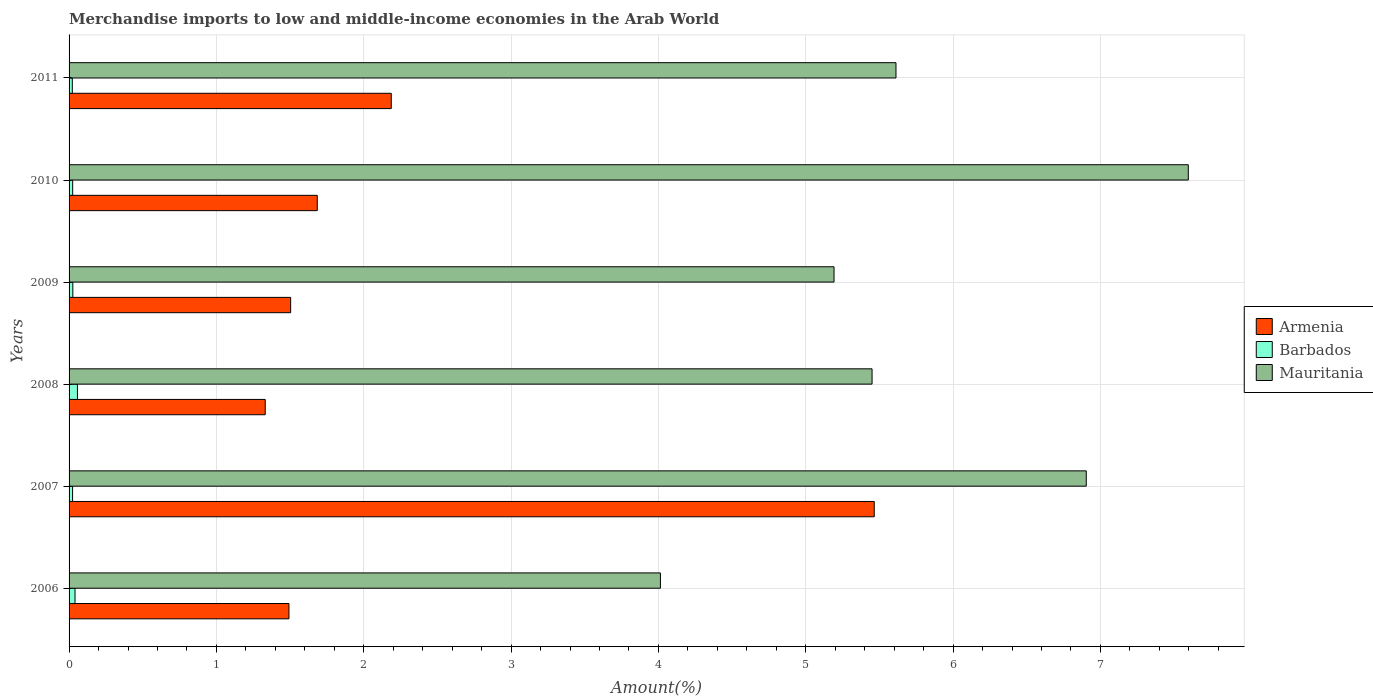How many different coloured bars are there?
Give a very brief answer. 3. How many groups of bars are there?
Your response must be concise. 6. Are the number of bars per tick equal to the number of legend labels?
Offer a very short reply. Yes. How many bars are there on the 1st tick from the top?
Keep it short and to the point. 3. In how many cases, is the number of bars for a given year not equal to the number of legend labels?
Offer a very short reply. 0. What is the percentage of amount earned from merchandise imports in Barbados in 2006?
Your answer should be compact. 0.04. Across all years, what is the maximum percentage of amount earned from merchandise imports in Barbados?
Your answer should be compact. 0.06. Across all years, what is the minimum percentage of amount earned from merchandise imports in Mauritania?
Provide a succinct answer. 4.01. In which year was the percentage of amount earned from merchandise imports in Barbados minimum?
Offer a very short reply. 2011. What is the total percentage of amount earned from merchandise imports in Armenia in the graph?
Your response must be concise. 13.66. What is the difference between the percentage of amount earned from merchandise imports in Mauritania in 2008 and that in 2011?
Offer a very short reply. -0.16. What is the difference between the percentage of amount earned from merchandise imports in Barbados in 2011 and the percentage of amount earned from merchandise imports in Armenia in 2008?
Make the answer very short. -1.31. What is the average percentage of amount earned from merchandise imports in Barbados per year?
Your response must be concise. 0.03. In the year 2008, what is the difference between the percentage of amount earned from merchandise imports in Barbados and percentage of amount earned from merchandise imports in Armenia?
Your answer should be compact. -1.27. What is the ratio of the percentage of amount earned from merchandise imports in Mauritania in 2010 to that in 2011?
Give a very brief answer. 1.35. Is the percentage of amount earned from merchandise imports in Armenia in 2008 less than that in 2010?
Provide a short and direct response. Yes. What is the difference between the highest and the second highest percentage of amount earned from merchandise imports in Mauritania?
Give a very brief answer. 0.69. What is the difference between the highest and the lowest percentage of amount earned from merchandise imports in Mauritania?
Offer a very short reply. 3.58. Is the sum of the percentage of amount earned from merchandise imports in Armenia in 2006 and 2007 greater than the maximum percentage of amount earned from merchandise imports in Barbados across all years?
Keep it short and to the point. Yes. What does the 3rd bar from the top in 2009 represents?
Provide a succinct answer. Armenia. What does the 1st bar from the bottom in 2011 represents?
Your answer should be very brief. Armenia. Is it the case that in every year, the sum of the percentage of amount earned from merchandise imports in Armenia and percentage of amount earned from merchandise imports in Barbados is greater than the percentage of amount earned from merchandise imports in Mauritania?
Your answer should be compact. No. Are all the bars in the graph horizontal?
Your response must be concise. Yes. Are the values on the major ticks of X-axis written in scientific E-notation?
Provide a short and direct response. No. Does the graph contain any zero values?
Ensure brevity in your answer.  No. Where does the legend appear in the graph?
Provide a short and direct response. Center right. How many legend labels are there?
Make the answer very short. 3. How are the legend labels stacked?
Give a very brief answer. Vertical. What is the title of the graph?
Make the answer very short. Merchandise imports to low and middle-income economies in the Arab World. Does "Libya" appear as one of the legend labels in the graph?
Offer a very short reply. No. What is the label or title of the X-axis?
Your answer should be compact. Amount(%). What is the Amount(%) in Armenia in 2006?
Your answer should be compact. 1.49. What is the Amount(%) of Barbados in 2006?
Offer a terse response. 0.04. What is the Amount(%) in Mauritania in 2006?
Keep it short and to the point. 4.01. What is the Amount(%) in Armenia in 2007?
Provide a succinct answer. 5.47. What is the Amount(%) in Barbados in 2007?
Your answer should be compact. 0.02. What is the Amount(%) of Mauritania in 2007?
Offer a very short reply. 6.9. What is the Amount(%) of Armenia in 2008?
Keep it short and to the point. 1.33. What is the Amount(%) of Barbados in 2008?
Give a very brief answer. 0.06. What is the Amount(%) in Mauritania in 2008?
Your response must be concise. 5.45. What is the Amount(%) of Armenia in 2009?
Offer a very short reply. 1.5. What is the Amount(%) in Barbados in 2009?
Provide a short and direct response. 0.03. What is the Amount(%) of Mauritania in 2009?
Make the answer very short. 5.19. What is the Amount(%) in Armenia in 2010?
Provide a succinct answer. 1.68. What is the Amount(%) in Barbados in 2010?
Offer a terse response. 0.02. What is the Amount(%) of Mauritania in 2010?
Give a very brief answer. 7.6. What is the Amount(%) in Armenia in 2011?
Offer a terse response. 2.19. What is the Amount(%) of Barbados in 2011?
Offer a terse response. 0.02. What is the Amount(%) in Mauritania in 2011?
Your answer should be very brief. 5.61. Across all years, what is the maximum Amount(%) in Armenia?
Your response must be concise. 5.47. Across all years, what is the maximum Amount(%) of Barbados?
Your answer should be very brief. 0.06. Across all years, what is the maximum Amount(%) of Mauritania?
Offer a very short reply. 7.6. Across all years, what is the minimum Amount(%) of Armenia?
Make the answer very short. 1.33. Across all years, what is the minimum Amount(%) in Barbados?
Your response must be concise. 0.02. Across all years, what is the minimum Amount(%) in Mauritania?
Your answer should be compact. 4.01. What is the total Amount(%) of Armenia in the graph?
Your response must be concise. 13.66. What is the total Amount(%) in Barbados in the graph?
Your response must be concise. 0.19. What is the total Amount(%) in Mauritania in the graph?
Ensure brevity in your answer.  34.77. What is the difference between the Amount(%) of Armenia in 2006 and that in 2007?
Keep it short and to the point. -3.97. What is the difference between the Amount(%) of Barbados in 2006 and that in 2007?
Your response must be concise. 0.02. What is the difference between the Amount(%) in Mauritania in 2006 and that in 2007?
Offer a very short reply. -2.89. What is the difference between the Amount(%) in Armenia in 2006 and that in 2008?
Give a very brief answer. 0.16. What is the difference between the Amount(%) of Barbados in 2006 and that in 2008?
Give a very brief answer. -0.02. What is the difference between the Amount(%) of Mauritania in 2006 and that in 2008?
Provide a short and direct response. -1.44. What is the difference between the Amount(%) in Armenia in 2006 and that in 2009?
Offer a terse response. -0.01. What is the difference between the Amount(%) of Barbados in 2006 and that in 2009?
Make the answer very short. 0.01. What is the difference between the Amount(%) in Mauritania in 2006 and that in 2009?
Your answer should be compact. -1.18. What is the difference between the Amount(%) in Armenia in 2006 and that in 2010?
Ensure brevity in your answer.  -0.19. What is the difference between the Amount(%) in Barbados in 2006 and that in 2010?
Keep it short and to the point. 0.02. What is the difference between the Amount(%) in Mauritania in 2006 and that in 2010?
Offer a terse response. -3.58. What is the difference between the Amount(%) of Armenia in 2006 and that in 2011?
Give a very brief answer. -0.69. What is the difference between the Amount(%) of Barbados in 2006 and that in 2011?
Offer a very short reply. 0.02. What is the difference between the Amount(%) of Mauritania in 2006 and that in 2011?
Your answer should be very brief. -1.6. What is the difference between the Amount(%) of Armenia in 2007 and that in 2008?
Offer a very short reply. 4.13. What is the difference between the Amount(%) of Barbados in 2007 and that in 2008?
Keep it short and to the point. -0.03. What is the difference between the Amount(%) of Mauritania in 2007 and that in 2008?
Your answer should be compact. 1.45. What is the difference between the Amount(%) of Armenia in 2007 and that in 2009?
Offer a very short reply. 3.96. What is the difference between the Amount(%) of Barbados in 2007 and that in 2009?
Keep it short and to the point. -0. What is the difference between the Amount(%) of Mauritania in 2007 and that in 2009?
Provide a succinct answer. 1.71. What is the difference between the Amount(%) in Armenia in 2007 and that in 2010?
Make the answer very short. 3.78. What is the difference between the Amount(%) of Barbados in 2007 and that in 2010?
Make the answer very short. -0. What is the difference between the Amount(%) of Mauritania in 2007 and that in 2010?
Give a very brief answer. -0.69. What is the difference between the Amount(%) of Armenia in 2007 and that in 2011?
Make the answer very short. 3.28. What is the difference between the Amount(%) in Barbados in 2007 and that in 2011?
Keep it short and to the point. 0. What is the difference between the Amount(%) of Mauritania in 2007 and that in 2011?
Your answer should be very brief. 1.29. What is the difference between the Amount(%) of Armenia in 2008 and that in 2009?
Offer a very short reply. -0.17. What is the difference between the Amount(%) of Barbados in 2008 and that in 2009?
Your answer should be compact. 0.03. What is the difference between the Amount(%) of Mauritania in 2008 and that in 2009?
Keep it short and to the point. 0.26. What is the difference between the Amount(%) of Armenia in 2008 and that in 2010?
Give a very brief answer. -0.35. What is the difference between the Amount(%) in Barbados in 2008 and that in 2010?
Provide a succinct answer. 0.03. What is the difference between the Amount(%) in Mauritania in 2008 and that in 2010?
Provide a short and direct response. -2.15. What is the difference between the Amount(%) in Armenia in 2008 and that in 2011?
Your response must be concise. -0.86. What is the difference between the Amount(%) in Barbados in 2008 and that in 2011?
Your answer should be very brief. 0.03. What is the difference between the Amount(%) of Mauritania in 2008 and that in 2011?
Keep it short and to the point. -0.16. What is the difference between the Amount(%) in Armenia in 2009 and that in 2010?
Keep it short and to the point. -0.18. What is the difference between the Amount(%) in Barbados in 2009 and that in 2010?
Provide a succinct answer. 0. What is the difference between the Amount(%) of Mauritania in 2009 and that in 2010?
Keep it short and to the point. -2.4. What is the difference between the Amount(%) of Armenia in 2009 and that in 2011?
Your answer should be compact. -0.68. What is the difference between the Amount(%) of Barbados in 2009 and that in 2011?
Make the answer very short. 0. What is the difference between the Amount(%) of Mauritania in 2009 and that in 2011?
Keep it short and to the point. -0.42. What is the difference between the Amount(%) in Armenia in 2010 and that in 2011?
Provide a short and direct response. -0.5. What is the difference between the Amount(%) of Barbados in 2010 and that in 2011?
Ensure brevity in your answer.  0. What is the difference between the Amount(%) in Mauritania in 2010 and that in 2011?
Make the answer very short. 1.98. What is the difference between the Amount(%) in Armenia in 2006 and the Amount(%) in Barbados in 2007?
Ensure brevity in your answer.  1.47. What is the difference between the Amount(%) in Armenia in 2006 and the Amount(%) in Mauritania in 2007?
Make the answer very short. -5.41. What is the difference between the Amount(%) in Barbados in 2006 and the Amount(%) in Mauritania in 2007?
Your response must be concise. -6.86. What is the difference between the Amount(%) of Armenia in 2006 and the Amount(%) of Barbados in 2008?
Provide a succinct answer. 1.44. What is the difference between the Amount(%) of Armenia in 2006 and the Amount(%) of Mauritania in 2008?
Offer a very short reply. -3.96. What is the difference between the Amount(%) of Barbados in 2006 and the Amount(%) of Mauritania in 2008?
Provide a short and direct response. -5.41. What is the difference between the Amount(%) in Armenia in 2006 and the Amount(%) in Barbados in 2009?
Provide a short and direct response. 1.47. What is the difference between the Amount(%) of Armenia in 2006 and the Amount(%) of Mauritania in 2009?
Provide a short and direct response. -3.7. What is the difference between the Amount(%) of Barbados in 2006 and the Amount(%) of Mauritania in 2009?
Your answer should be compact. -5.15. What is the difference between the Amount(%) of Armenia in 2006 and the Amount(%) of Barbados in 2010?
Provide a succinct answer. 1.47. What is the difference between the Amount(%) of Armenia in 2006 and the Amount(%) of Mauritania in 2010?
Make the answer very short. -6.1. What is the difference between the Amount(%) of Barbados in 2006 and the Amount(%) of Mauritania in 2010?
Offer a very short reply. -7.56. What is the difference between the Amount(%) of Armenia in 2006 and the Amount(%) of Barbados in 2011?
Provide a succinct answer. 1.47. What is the difference between the Amount(%) of Armenia in 2006 and the Amount(%) of Mauritania in 2011?
Make the answer very short. -4.12. What is the difference between the Amount(%) in Barbados in 2006 and the Amount(%) in Mauritania in 2011?
Your answer should be very brief. -5.57. What is the difference between the Amount(%) of Armenia in 2007 and the Amount(%) of Barbados in 2008?
Offer a terse response. 5.41. What is the difference between the Amount(%) of Armenia in 2007 and the Amount(%) of Mauritania in 2008?
Ensure brevity in your answer.  0.01. What is the difference between the Amount(%) of Barbados in 2007 and the Amount(%) of Mauritania in 2008?
Offer a terse response. -5.43. What is the difference between the Amount(%) in Armenia in 2007 and the Amount(%) in Barbados in 2009?
Give a very brief answer. 5.44. What is the difference between the Amount(%) in Armenia in 2007 and the Amount(%) in Mauritania in 2009?
Your answer should be compact. 0.27. What is the difference between the Amount(%) in Barbados in 2007 and the Amount(%) in Mauritania in 2009?
Make the answer very short. -5.17. What is the difference between the Amount(%) of Armenia in 2007 and the Amount(%) of Barbados in 2010?
Keep it short and to the point. 5.44. What is the difference between the Amount(%) in Armenia in 2007 and the Amount(%) in Mauritania in 2010?
Your answer should be very brief. -2.13. What is the difference between the Amount(%) in Barbados in 2007 and the Amount(%) in Mauritania in 2010?
Provide a short and direct response. -7.57. What is the difference between the Amount(%) in Armenia in 2007 and the Amount(%) in Barbados in 2011?
Keep it short and to the point. 5.44. What is the difference between the Amount(%) of Armenia in 2007 and the Amount(%) of Mauritania in 2011?
Your answer should be very brief. -0.15. What is the difference between the Amount(%) in Barbados in 2007 and the Amount(%) in Mauritania in 2011?
Make the answer very short. -5.59. What is the difference between the Amount(%) in Armenia in 2008 and the Amount(%) in Barbados in 2009?
Offer a very short reply. 1.31. What is the difference between the Amount(%) of Armenia in 2008 and the Amount(%) of Mauritania in 2009?
Provide a succinct answer. -3.86. What is the difference between the Amount(%) in Barbados in 2008 and the Amount(%) in Mauritania in 2009?
Keep it short and to the point. -5.14. What is the difference between the Amount(%) of Armenia in 2008 and the Amount(%) of Barbados in 2010?
Provide a succinct answer. 1.31. What is the difference between the Amount(%) of Armenia in 2008 and the Amount(%) of Mauritania in 2010?
Offer a terse response. -6.27. What is the difference between the Amount(%) in Barbados in 2008 and the Amount(%) in Mauritania in 2010?
Give a very brief answer. -7.54. What is the difference between the Amount(%) in Armenia in 2008 and the Amount(%) in Barbados in 2011?
Provide a succinct answer. 1.31. What is the difference between the Amount(%) in Armenia in 2008 and the Amount(%) in Mauritania in 2011?
Keep it short and to the point. -4.28. What is the difference between the Amount(%) of Barbados in 2008 and the Amount(%) of Mauritania in 2011?
Offer a very short reply. -5.56. What is the difference between the Amount(%) in Armenia in 2009 and the Amount(%) in Barbados in 2010?
Provide a short and direct response. 1.48. What is the difference between the Amount(%) of Armenia in 2009 and the Amount(%) of Mauritania in 2010?
Your answer should be very brief. -6.09. What is the difference between the Amount(%) of Barbados in 2009 and the Amount(%) of Mauritania in 2010?
Ensure brevity in your answer.  -7.57. What is the difference between the Amount(%) of Armenia in 2009 and the Amount(%) of Barbados in 2011?
Your answer should be very brief. 1.48. What is the difference between the Amount(%) of Armenia in 2009 and the Amount(%) of Mauritania in 2011?
Ensure brevity in your answer.  -4.11. What is the difference between the Amount(%) in Barbados in 2009 and the Amount(%) in Mauritania in 2011?
Offer a terse response. -5.59. What is the difference between the Amount(%) in Armenia in 2010 and the Amount(%) in Barbados in 2011?
Provide a short and direct response. 1.66. What is the difference between the Amount(%) of Armenia in 2010 and the Amount(%) of Mauritania in 2011?
Keep it short and to the point. -3.93. What is the difference between the Amount(%) in Barbados in 2010 and the Amount(%) in Mauritania in 2011?
Provide a short and direct response. -5.59. What is the average Amount(%) in Armenia per year?
Offer a very short reply. 2.28. What is the average Amount(%) in Barbados per year?
Offer a very short reply. 0.03. What is the average Amount(%) of Mauritania per year?
Provide a short and direct response. 5.79. In the year 2006, what is the difference between the Amount(%) in Armenia and Amount(%) in Barbados?
Provide a short and direct response. 1.45. In the year 2006, what is the difference between the Amount(%) of Armenia and Amount(%) of Mauritania?
Your answer should be very brief. -2.52. In the year 2006, what is the difference between the Amount(%) in Barbados and Amount(%) in Mauritania?
Offer a very short reply. -3.97. In the year 2007, what is the difference between the Amount(%) in Armenia and Amount(%) in Barbados?
Your answer should be compact. 5.44. In the year 2007, what is the difference between the Amount(%) of Armenia and Amount(%) of Mauritania?
Ensure brevity in your answer.  -1.44. In the year 2007, what is the difference between the Amount(%) of Barbados and Amount(%) of Mauritania?
Make the answer very short. -6.88. In the year 2008, what is the difference between the Amount(%) of Armenia and Amount(%) of Barbados?
Offer a very short reply. 1.27. In the year 2008, what is the difference between the Amount(%) of Armenia and Amount(%) of Mauritania?
Offer a terse response. -4.12. In the year 2008, what is the difference between the Amount(%) in Barbados and Amount(%) in Mauritania?
Ensure brevity in your answer.  -5.39. In the year 2009, what is the difference between the Amount(%) in Armenia and Amount(%) in Barbados?
Provide a short and direct response. 1.48. In the year 2009, what is the difference between the Amount(%) of Armenia and Amount(%) of Mauritania?
Provide a short and direct response. -3.69. In the year 2009, what is the difference between the Amount(%) of Barbados and Amount(%) of Mauritania?
Make the answer very short. -5.17. In the year 2010, what is the difference between the Amount(%) in Armenia and Amount(%) in Barbados?
Make the answer very short. 1.66. In the year 2010, what is the difference between the Amount(%) in Armenia and Amount(%) in Mauritania?
Offer a very short reply. -5.91. In the year 2010, what is the difference between the Amount(%) of Barbados and Amount(%) of Mauritania?
Keep it short and to the point. -7.57. In the year 2011, what is the difference between the Amount(%) in Armenia and Amount(%) in Barbados?
Make the answer very short. 2.16. In the year 2011, what is the difference between the Amount(%) of Armenia and Amount(%) of Mauritania?
Offer a very short reply. -3.43. In the year 2011, what is the difference between the Amount(%) in Barbados and Amount(%) in Mauritania?
Provide a short and direct response. -5.59. What is the ratio of the Amount(%) of Armenia in 2006 to that in 2007?
Provide a short and direct response. 0.27. What is the ratio of the Amount(%) of Barbados in 2006 to that in 2007?
Offer a very short reply. 1.69. What is the ratio of the Amount(%) in Mauritania in 2006 to that in 2007?
Provide a succinct answer. 0.58. What is the ratio of the Amount(%) in Armenia in 2006 to that in 2008?
Provide a short and direct response. 1.12. What is the ratio of the Amount(%) in Barbados in 2006 to that in 2008?
Give a very brief answer. 0.71. What is the ratio of the Amount(%) in Mauritania in 2006 to that in 2008?
Your answer should be very brief. 0.74. What is the ratio of the Amount(%) in Barbados in 2006 to that in 2009?
Offer a terse response. 1.58. What is the ratio of the Amount(%) in Mauritania in 2006 to that in 2009?
Your answer should be very brief. 0.77. What is the ratio of the Amount(%) of Armenia in 2006 to that in 2010?
Make the answer very short. 0.89. What is the ratio of the Amount(%) of Barbados in 2006 to that in 2010?
Provide a short and direct response. 1.65. What is the ratio of the Amount(%) in Mauritania in 2006 to that in 2010?
Give a very brief answer. 0.53. What is the ratio of the Amount(%) in Armenia in 2006 to that in 2011?
Make the answer very short. 0.68. What is the ratio of the Amount(%) in Barbados in 2006 to that in 2011?
Your answer should be very brief. 1.83. What is the ratio of the Amount(%) of Mauritania in 2006 to that in 2011?
Make the answer very short. 0.72. What is the ratio of the Amount(%) of Armenia in 2007 to that in 2008?
Your answer should be very brief. 4.1. What is the ratio of the Amount(%) of Barbados in 2007 to that in 2008?
Offer a very short reply. 0.42. What is the ratio of the Amount(%) of Mauritania in 2007 to that in 2008?
Provide a succinct answer. 1.27. What is the ratio of the Amount(%) of Armenia in 2007 to that in 2009?
Keep it short and to the point. 3.63. What is the ratio of the Amount(%) of Barbados in 2007 to that in 2009?
Keep it short and to the point. 0.93. What is the ratio of the Amount(%) in Mauritania in 2007 to that in 2009?
Offer a terse response. 1.33. What is the ratio of the Amount(%) of Armenia in 2007 to that in 2010?
Ensure brevity in your answer.  3.24. What is the ratio of the Amount(%) in Barbados in 2007 to that in 2010?
Your response must be concise. 0.97. What is the ratio of the Amount(%) in Mauritania in 2007 to that in 2010?
Your answer should be very brief. 0.91. What is the ratio of the Amount(%) of Armenia in 2007 to that in 2011?
Your answer should be very brief. 2.5. What is the ratio of the Amount(%) in Barbados in 2007 to that in 2011?
Provide a short and direct response. 1.08. What is the ratio of the Amount(%) of Mauritania in 2007 to that in 2011?
Offer a very short reply. 1.23. What is the ratio of the Amount(%) in Armenia in 2008 to that in 2009?
Provide a short and direct response. 0.89. What is the ratio of the Amount(%) in Barbados in 2008 to that in 2009?
Offer a very short reply. 2.22. What is the ratio of the Amount(%) in Mauritania in 2008 to that in 2009?
Offer a very short reply. 1.05. What is the ratio of the Amount(%) in Armenia in 2008 to that in 2010?
Keep it short and to the point. 0.79. What is the ratio of the Amount(%) in Barbados in 2008 to that in 2010?
Provide a succinct answer. 2.32. What is the ratio of the Amount(%) of Mauritania in 2008 to that in 2010?
Offer a very short reply. 0.72. What is the ratio of the Amount(%) of Armenia in 2008 to that in 2011?
Offer a very short reply. 0.61. What is the ratio of the Amount(%) of Barbados in 2008 to that in 2011?
Offer a terse response. 2.58. What is the ratio of the Amount(%) of Mauritania in 2008 to that in 2011?
Provide a succinct answer. 0.97. What is the ratio of the Amount(%) of Armenia in 2009 to that in 2010?
Offer a terse response. 0.89. What is the ratio of the Amount(%) in Barbados in 2009 to that in 2010?
Offer a very short reply. 1.04. What is the ratio of the Amount(%) of Mauritania in 2009 to that in 2010?
Make the answer very short. 0.68. What is the ratio of the Amount(%) in Armenia in 2009 to that in 2011?
Offer a very short reply. 0.69. What is the ratio of the Amount(%) of Barbados in 2009 to that in 2011?
Provide a succinct answer. 1.16. What is the ratio of the Amount(%) of Mauritania in 2009 to that in 2011?
Make the answer very short. 0.93. What is the ratio of the Amount(%) of Armenia in 2010 to that in 2011?
Ensure brevity in your answer.  0.77. What is the ratio of the Amount(%) of Barbados in 2010 to that in 2011?
Give a very brief answer. 1.11. What is the ratio of the Amount(%) of Mauritania in 2010 to that in 2011?
Offer a very short reply. 1.35. What is the difference between the highest and the second highest Amount(%) of Armenia?
Ensure brevity in your answer.  3.28. What is the difference between the highest and the second highest Amount(%) of Barbados?
Make the answer very short. 0.02. What is the difference between the highest and the second highest Amount(%) in Mauritania?
Your response must be concise. 0.69. What is the difference between the highest and the lowest Amount(%) of Armenia?
Your response must be concise. 4.13. What is the difference between the highest and the lowest Amount(%) of Barbados?
Offer a very short reply. 0.03. What is the difference between the highest and the lowest Amount(%) of Mauritania?
Your response must be concise. 3.58. 